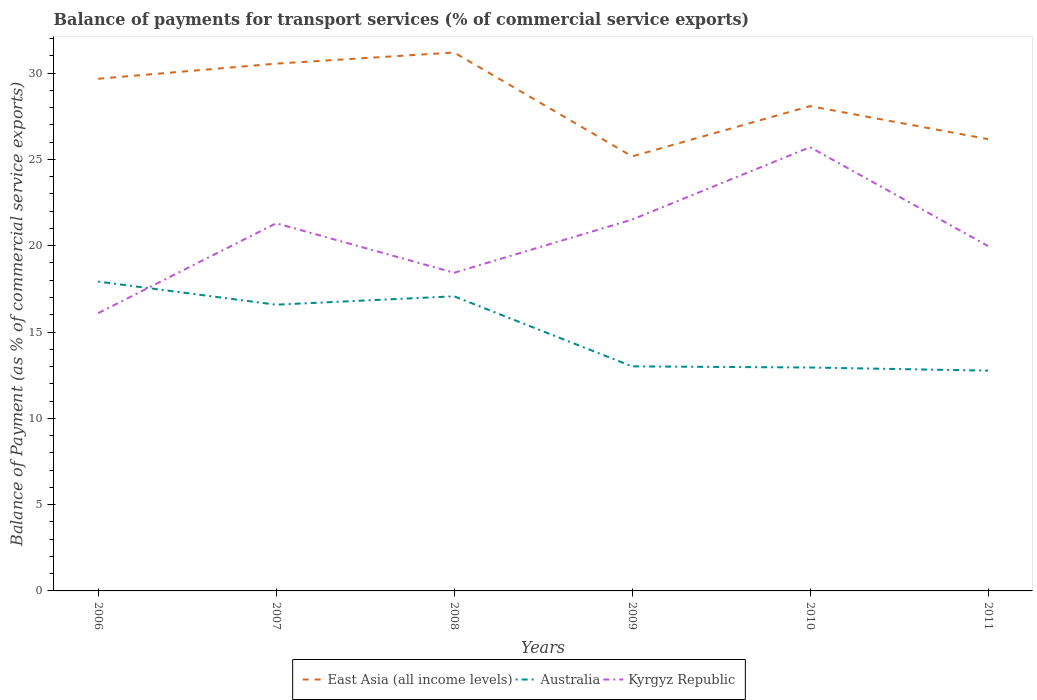How many different coloured lines are there?
Your answer should be very brief. 3. Does the line corresponding to East Asia (all income levels) intersect with the line corresponding to Australia?
Offer a terse response. No. Across all years, what is the maximum balance of payments for transport services in Kyrgyz Republic?
Keep it short and to the point. 16.09. What is the total balance of payments for transport services in East Asia (all income levels) in the graph?
Your answer should be very brief. 5.02. What is the difference between the highest and the second highest balance of payments for transport services in East Asia (all income levels)?
Give a very brief answer. 6.02. Is the balance of payments for transport services in East Asia (all income levels) strictly greater than the balance of payments for transport services in Australia over the years?
Give a very brief answer. No. How many lines are there?
Offer a very short reply. 3. What is the difference between two consecutive major ticks on the Y-axis?
Offer a terse response. 5. Does the graph contain any zero values?
Your response must be concise. No. Where does the legend appear in the graph?
Offer a very short reply. Bottom center. How many legend labels are there?
Provide a succinct answer. 3. What is the title of the graph?
Your answer should be very brief. Balance of payments for transport services (% of commercial service exports). Does "Swaziland" appear as one of the legend labels in the graph?
Ensure brevity in your answer.  No. What is the label or title of the Y-axis?
Your answer should be very brief. Balance of Payment (as % of commercial service exports). What is the Balance of Payment (as % of commercial service exports) of East Asia (all income levels) in 2006?
Offer a very short reply. 29.67. What is the Balance of Payment (as % of commercial service exports) in Australia in 2006?
Give a very brief answer. 17.92. What is the Balance of Payment (as % of commercial service exports) in Kyrgyz Republic in 2006?
Offer a very short reply. 16.09. What is the Balance of Payment (as % of commercial service exports) of East Asia (all income levels) in 2007?
Provide a short and direct response. 30.55. What is the Balance of Payment (as % of commercial service exports) in Australia in 2007?
Keep it short and to the point. 16.58. What is the Balance of Payment (as % of commercial service exports) of Kyrgyz Republic in 2007?
Keep it short and to the point. 21.3. What is the Balance of Payment (as % of commercial service exports) in East Asia (all income levels) in 2008?
Your answer should be very brief. 31.2. What is the Balance of Payment (as % of commercial service exports) in Australia in 2008?
Ensure brevity in your answer.  17.07. What is the Balance of Payment (as % of commercial service exports) of Kyrgyz Republic in 2008?
Give a very brief answer. 18.43. What is the Balance of Payment (as % of commercial service exports) in East Asia (all income levels) in 2009?
Your response must be concise. 25.18. What is the Balance of Payment (as % of commercial service exports) of Australia in 2009?
Your response must be concise. 13.01. What is the Balance of Payment (as % of commercial service exports) of Kyrgyz Republic in 2009?
Ensure brevity in your answer.  21.52. What is the Balance of Payment (as % of commercial service exports) of East Asia (all income levels) in 2010?
Your response must be concise. 28.09. What is the Balance of Payment (as % of commercial service exports) of Australia in 2010?
Offer a terse response. 12.94. What is the Balance of Payment (as % of commercial service exports) of Kyrgyz Republic in 2010?
Keep it short and to the point. 25.71. What is the Balance of Payment (as % of commercial service exports) in East Asia (all income levels) in 2011?
Your answer should be compact. 26.18. What is the Balance of Payment (as % of commercial service exports) in Australia in 2011?
Ensure brevity in your answer.  12.76. What is the Balance of Payment (as % of commercial service exports) in Kyrgyz Republic in 2011?
Offer a very short reply. 19.98. Across all years, what is the maximum Balance of Payment (as % of commercial service exports) in East Asia (all income levels)?
Your answer should be compact. 31.2. Across all years, what is the maximum Balance of Payment (as % of commercial service exports) of Australia?
Offer a terse response. 17.92. Across all years, what is the maximum Balance of Payment (as % of commercial service exports) of Kyrgyz Republic?
Provide a succinct answer. 25.71. Across all years, what is the minimum Balance of Payment (as % of commercial service exports) of East Asia (all income levels)?
Offer a terse response. 25.18. Across all years, what is the minimum Balance of Payment (as % of commercial service exports) of Australia?
Ensure brevity in your answer.  12.76. Across all years, what is the minimum Balance of Payment (as % of commercial service exports) of Kyrgyz Republic?
Provide a short and direct response. 16.09. What is the total Balance of Payment (as % of commercial service exports) of East Asia (all income levels) in the graph?
Give a very brief answer. 170.86. What is the total Balance of Payment (as % of commercial service exports) in Australia in the graph?
Your answer should be compact. 90.29. What is the total Balance of Payment (as % of commercial service exports) in Kyrgyz Republic in the graph?
Provide a short and direct response. 123.04. What is the difference between the Balance of Payment (as % of commercial service exports) of East Asia (all income levels) in 2006 and that in 2007?
Ensure brevity in your answer.  -0.88. What is the difference between the Balance of Payment (as % of commercial service exports) of Australia in 2006 and that in 2007?
Your answer should be very brief. 1.34. What is the difference between the Balance of Payment (as % of commercial service exports) in Kyrgyz Republic in 2006 and that in 2007?
Offer a very short reply. -5.21. What is the difference between the Balance of Payment (as % of commercial service exports) of East Asia (all income levels) in 2006 and that in 2008?
Keep it short and to the point. -1.52. What is the difference between the Balance of Payment (as % of commercial service exports) of Australia in 2006 and that in 2008?
Ensure brevity in your answer.  0.85. What is the difference between the Balance of Payment (as % of commercial service exports) in Kyrgyz Republic in 2006 and that in 2008?
Your response must be concise. -2.34. What is the difference between the Balance of Payment (as % of commercial service exports) in East Asia (all income levels) in 2006 and that in 2009?
Offer a very short reply. 4.5. What is the difference between the Balance of Payment (as % of commercial service exports) in Australia in 2006 and that in 2009?
Give a very brief answer. 4.91. What is the difference between the Balance of Payment (as % of commercial service exports) in Kyrgyz Republic in 2006 and that in 2009?
Provide a short and direct response. -5.42. What is the difference between the Balance of Payment (as % of commercial service exports) in East Asia (all income levels) in 2006 and that in 2010?
Provide a short and direct response. 1.59. What is the difference between the Balance of Payment (as % of commercial service exports) in Australia in 2006 and that in 2010?
Keep it short and to the point. 4.98. What is the difference between the Balance of Payment (as % of commercial service exports) of Kyrgyz Republic in 2006 and that in 2010?
Provide a short and direct response. -9.62. What is the difference between the Balance of Payment (as % of commercial service exports) of East Asia (all income levels) in 2006 and that in 2011?
Offer a very short reply. 3.5. What is the difference between the Balance of Payment (as % of commercial service exports) in Australia in 2006 and that in 2011?
Keep it short and to the point. 5.16. What is the difference between the Balance of Payment (as % of commercial service exports) of Kyrgyz Republic in 2006 and that in 2011?
Give a very brief answer. -3.89. What is the difference between the Balance of Payment (as % of commercial service exports) in East Asia (all income levels) in 2007 and that in 2008?
Your response must be concise. -0.65. What is the difference between the Balance of Payment (as % of commercial service exports) of Australia in 2007 and that in 2008?
Ensure brevity in your answer.  -0.49. What is the difference between the Balance of Payment (as % of commercial service exports) in Kyrgyz Republic in 2007 and that in 2008?
Ensure brevity in your answer.  2.87. What is the difference between the Balance of Payment (as % of commercial service exports) in East Asia (all income levels) in 2007 and that in 2009?
Provide a short and direct response. 5.37. What is the difference between the Balance of Payment (as % of commercial service exports) in Australia in 2007 and that in 2009?
Offer a terse response. 3.57. What is the difference between the Balance of Payment (as % of commercial service exports) of Kyrgyz Republic in 2007 and that in 2009?
Your answer should be very brief. -0.21. What is the difference between the Balance of Payment (as % of commercial service exports) of East Asia (all income levels) in 2007 and that in 2010?
Your answer should be very brief. 2.46. What is the difference between the Balance of Payment (as % of commercial service exports) in Australia in 2007 and that in 2010?
Make the answer very short. 3.64. What is the difference between the Balance of Payment (as % of commercial service exports) of Kyrgyz Republic in 2007 and that in 2010?
Give a very brief answer. -4.41. What is the difference between the Balance of Payment (as % of commercial service exports) in East Asia (all income levels) in 2007 and that in 2011?
Offer a terse response. 4.37. What is the difference between the Balance of Payment (as % of commercial service exports) of Australia in 2007 and that in 2011?
Offer a terse response. 3.82. What is the difference between the Balance of Payment (as % of commercial service exports) in Kyrgyz Republic in 2007 and that in 2011?
Your response must be concise. 1.32. What is the difference between the Balance of Payment (as % of commercial service exports) in East Asia (all income levels) in 2008 and that in 2009?
Keep it short and to the point. 6.02. What is the difference between the Balance of Payment (as % of commercial service exports) in Australia in 2008 and that in 2009?
Keep it short and to the point. 4.06. What is the difference between the Balance of Payment (as % of commercial service exports) of Kyrgyz Republic in 2008 and that in 2009?
Provide a succinct answer. -3.08. What is the difference between the Balance of Payment (as % of commercial service exports) of East Asia (all income levels) in 2008 and that in 2010?
Your answer should be compact. 3.11. What is the difference between the Balance of Payment (as % of commercial service exports) of Australia in 2008 and that in 2010?
Give a very brief answer. 4.12. What is the difference between the Balance of Payment (as % of commercial service exports) of Kyrgyz Republic in 2008 and that in 2010?
Your answer should be very brief. -7.28. What is the difference between the Balance of Payment (as % of commercial service exports) in East Asia (all income levels) in 2008 and that in 2011?
Offer a terse response. 5.02. What is the difference between the Balance of Payment (as % of commercial service exports) in Australia in 2008 and that in 2011?
Offer a terse response. 4.31. What is the difference between the Balance of Payment (as % of commercial service exports) of Kyrgyz Republic in 2008 and that in 2011?
Ensure brevity in your answer.  -1.55. What is the difference between the Balance of Payment (as % of commercial service exports) in East Asia (all income levels) in 2009 and that in 2010?
Keep it short and to the point. -2.91. What is the difference between the Balance of Payment (as % of commercial service exports) in Australia in 2009 and that in 2010?
Provide a short and direct response. 0.06. What is the difference between the Balance of Payment (as % of commercial service exports) in Kyrgyz Republic in 2009 and that in 2010?
Give a very brief answer. -4.19. What is the difference between the Balance of Payment (as % of commercial service exports) of East Asia (all income levels) in 2009 and that in 2011?
Provide a succinct answer. -1. What is the difference between the Balance of Payment (as % of commercial service exports) of Australia in 2009 and that in 2011?
Give a very brief answer. 0.25. What is the difference between the Balance of Payment (as % of commercial service exports) in Kyrgyz Republic in 2009 and that in 2011?
Provide a short and direct response. 1.53. What is the difference between the Balance of Payment (as % of commercial service exports) in East Asia (all income levels) in 2010 and that in 2011?
Offer a very short reply. 1.91. What is the difference between the Balance of Payment (as % of commercial service exports) of Australia in 2010 and that in 2011?
Offer a terse response. 0.18. What is the difference between the Balance of Payment (as % of commercial service exports) of Kyrgyz Republic in 2010 and that in 2011?
Make the answer very short. 5.73. What is the difference between the Balance of Payment (as % of commercial service exports) in East Asia (all income levels) in 2006 and the Balance of Payment (as % of commercial service exports) in Australia in 2007?
Offer a terse response. 13.09. What is the difference between the Balance of Payment (as % of commercial service exports) of East Asia (all income levels) in 2006 and the Balance of Payment (as % of commercial service exports) of Kyrgyz Republic in 2007?
Make the answer very short. 8.37. What is the difference between the Balance of Payment (as % of commercial service exports) of Australia in 2006 and the Balance of Payment (as % of commercial service exports) of Kyrgyz Republic in 2007?
Your answer should be compact. -3.38. What is the difference between the Balance of Payment (as % of commercial service exports) in East Asia (all income levels) in 2006 and the Balance of Payment (as % of commercial service exports) in Australia in 2008?
Keep it short and to the point. 12.6. What is the difference between the Balance of Payment (as % of commercial service exports) of East Asia (all income levels) in 2006 and the Balance of Payment (as % of commercial service exports) of Kyrgyz Republic in 2008?
Your answer should be very brief. 11.24. What is the difference between the Balance of Payment (as % of commercial service exports) in Australia in 2006 and the Balance of Payment (as % of commercial service exports) in Kyrgyz Republic in 2008?
Provide a short and direct response. -0.51. What is the difference between the Balance of Payment (as % of commercial service exports) of East Asia (all income levels) in 2006 and the Balance of Payment (as % of commercial service exports) of Australia in 2009?
Provide a succinct answer. 16.66. What is the difference between the Balance of Payment (as % of commercial service exports) of East Asia (all income levels) in 2006 and the Balance of Payment (as % of commercial service exports) of Kyrgyz Republic in 2009?
Ensure brevity in your answer.  8.16. What is the difference between the Balance of Payment (as % of commercial service exports) in Australia in 2006 and the Balance of Payment (as % of commercial service exports) in Kyrgyz Republic in 2009?
Give a very brief answer. -3.59. What is the difference between the Balance of Payment (as % of commercial service exports) in East Asia (all income levels) in 2006 and the Balance of Payment (as % of commercial service exports) in Australia in 2010?
Give a very brief answer. 16.73. What is the difference between the Balance of Payment (as % of commercial service exports) of East Asia (all income levels) in 2006 and the Balance of Payment (as % of commercial service exports) of Kyrgyz Republic in 2010?
Make the answer very short. 3.96. What is the difference between the Balance of Payment (as % of commercial service exports) in Australia in 2006 and the Balance of Payment (as % of commercial service exports) in Kyrgyz Republic in 2010?
Your answer should be very brief. -7.79. What is the difference between the Balance of Payment (as % of commercial service exports) of East Asia (all income levels) in 2006 and the Balance of Payment (as % of commercial service exports) of Australia in 2011?
Ensure brevity in your answer.  16.91. What is the difference between the Balance of Payment (as % of commercial service exports) of East Asia (all income levels) in 2006 and the Balance of Payment (as % of commercial service exports) of Kyrgyz Republic in 2011?
Your answer should be very brief. 9.69. What is the difference between the Balance of Payment (as % of commercial service exports) of Australia in 2006 and the Balance of Payment (as % of commercial service exports) of Kyrgyz Republic in 2011?
Offer a very short reply. -2.06. What is the difference between the Balance of Payment (as % of commercial service exports) of East Asia (all income levels) in 2007 and the Balance of Payment (as % of commercial service exports) of Australia in 2008?
Offer a very short reply. 13.48. What is the difference between the Balance of Payment (as % of commercial service exports) in East Asia (all income levels) in 2007 and the Balance of Payment (as % of commercial service exports) in Kyrgyz Republic in 2008?
Keep it short and to the point. 12.12. What is the difference between the Balance of Payment (as % of commercial service exports) in Australia in 2007 and the Balance of Payment (as % of commercial service exports) in Kyrgyz Republic in 2008?
Keep it short and to the point. -1.85. What is the difference between the Balance of Payment (as % of commercial service exports) of East Asia (all income levels) in 2007 and the Balance of Payment (as % of commercial service exports) of Australia in 2009?
Provide a succinct answer. 17.54. What is the difference between the Balance of Payment (as % of commercial service exports) in East Asia (all income levels) in 2007 and the Balance of Payment (as % of commercial service exports) in Kyrgyz Republic in 2009?
Give a very brief answer. 9.03. What is the difference between the Balance of Payment (as % of commercial service exports) of Australia in 2007 and the Balance of Payment (as % of commercial service exports) of Kyrgyz Republic in 2009?
Give a very brief answer. -4.93. What is the difference between the Balance of Payment (as % of commercial service exports) in East Asia (all income levels) in 2007 and the Balance of Payment (as % of commercial service exports) in Australia in 2010?
Ensure brevity in your answer.  17.6. What is the difference between the Balance of Payment (as % of commercial service exports) in East Asia (all income levels) in 2007 and the Balance of Payment (as % of commercial service exports) in Kyrgyz Republic in 2010?
Provide a succinct answer. 4.84. What is the difference between the Balance of Payment (as % of commercial service exports) in Australia in 2007 and the Balance of Payment (as % of commercial service exports) in Kyrgyz Republic in 2010?
Provide a short and direct response. -9.13. What is the difference between the Balance of Payment (as % of commercial service exports) of East Asia (all income levels) in 2007 and the Balance of Payment (as % of commercial service exports) of Australia in 2011?
Offer a terse response. 17.79. What is the difference between the Balance of Payment (as % of commercial service exports) of East Asia (all income levels) in 2007 and the Balance of Payment (as % of commercial service exports) of Kyrgyz Republic in 2011?
Offer a terse response. 10.57. What is the difference between the Balance of Payment (as % of commercial service exports) of Australia in 2007 and the Balance of Payment (as % of commercial service exports) of Kyrgyz Republic in 2011?
Keep it short and to the point. -3.4. What is the difference between the Balance of Payment (as % of commercial service exports) of East Asia (all income levels) in 2008 and the Balance of Payment (as % of commercial service exports) of Australia in 2009?
Provide a succinct answer. 18.19. What is the difference between the Balance of Payment (as % of commercial service exports) in East Asia (all income levels) in 2008 and the Balance of Payment (as % of commercial service exports) in Kyrgyz Republic in 2009?
Your response must be concise. 9.68. What is the difference between the Balance of Payment (as % of commercial service exports) of Australia in 2008 and the Balance of Payment (as % of commercial service exports) of Kyrgyz Republic in 2009?
Offer a very short reply. -4.45. What is the difference between the Balance of Payment (as % of commercial service exports) of East Asia (all income levels) in 2008 and the Balance of Payment (as % of commercial service exports) of Australia in 2010?
Provide a short and direct response. 18.25. What is the difference between the Balance of Payment (as % of commercial service exports) of East Asia (all income levels) in 2008 and the Balance of Payment (as % of commercial service exports) of Kyrgyz Republic in 2010?
Offer a terse response. 5.49. What is the difference between the Balance of Payment (as % of commercial service exports) of Australia in 2008 and the Balance of Payment (as % of commercial service exports) of Kyrgyz Republic in 2010?
Provide a short and direct response. -8.64. What is the difference between the Balance of Payment (as % of commercial service exports) in East Asia (all income levels) in 2008 and the Balance of Payment (as % of commercial service exports) in Australia in 2011?
Give a very brief answer. 18.43. What is the difference between the Balance of Payment (as % of commercial service exports) of East Asia (all income levels) in 2008 and the Balance of Payment (as % of commercial service exports) of Kyrgyz Republic in 2011?
Your answer should be compact. 11.21. What is the difference between the Balance of Payment (as % of commercial service exports) in Australia in 2008 and the Balance of Payment (as % of commercial service exports) in Kyrgyz Republic in 2011?
Offer a terse response. -2.91. What is the difference between the Balance of Payment (as % of commercial service exports) in East Asia (all income levels) in 2009 and the Balance of Payment (as % of commercial service exports) in Australia in 2010?
Your answer should be very brief. 12.23. What is the difference between the Balance of Payment (as % of commercial service exports) in East Asia (all income levels) in 2009 and the Balance of Payment (as % of commercial service exports) in Kyrgyz Republic in 2010?
Provide a short and direct response. -0.53. What is the difference between the Balance of Payment (as % of commercial service exports) in Australia in 2009 and the Balance of Payment (as % of commercial service exports) in Kyrgyz Republic in 2010?
Ensure brevity in your answer.  -12.7. What is the difference between the Balance of Payment (as % of commercial service exports) of East Asia (all income levels) in 2009 and the Balance of Payment (as % of commercial service exports) of Australia in 2011?
Your answer should be compact. 12.41. What is the difference between the Balance of Payment (as % of commercial service exports) of East Asia (all income levels) in 2009 and the Balance of Payment (as % of commercial service exports) of Kyrgyz Republic in 2011?
Your response must be concise. 5.19. What is the difference between the Balance of Payment (as % of commercial service exports) in Australia in 2009 and the Balance of Payment (as % of commercial service exports) in Kyrgyz Republic in 2011?
Your answer should be very brief. -6.97. What is the difference between the Balance of Payment (as % of commercial service exports) in East Asia (all income levels) in 2010 and the Balance of Payment (as % of commercial service exports) in Australia in 2011?
Provide a short and direct response. 15.32. What is the difference between the Balance of Payment (as % of commercial service exports) in East Asia (all income levels) in 2010 and the Balance of Payment (as % of commercial service exports) in Kyrgyz Republic in 2011?
Provide a short and direct response. 8.1. What is the difference between the Balance of Payment (as % of commercial service exports) of Australia in 2010 and the Balance of Payment (as % of commercial service exports) of Kyrgyz Republic in 2011?
Your answer should be very brief. -7.04. What is the average Balance of Payment (as % of commercial service exports) in East Asia (all income levels) per year?
Your answer should be compact. 28.48. What is the average Balance of Payment (as % of commercial service exports) in Australia per year?
Offer a very short reply. 15.05. What is the average Balance of Payment (as % of commercial service exports) in Kyrgyz Republic per year?
Keep it short and to the point. 20.51. In the year 2006, what is the difference between the Balance of Payment (as % of commercial service exports) in East Asia (all income levels) and Balance of Payment (as % of commercial service exports) in Australia?
Provide a succinct answer. 11.75. In the year 2006, what is the difference between the Balance of Payment (as % of commercial service exports) in East Asia (all income levels) and Balance of Payment (as % of commercial service exports) in Kyrgyz Republic?
Offer a terse response. 13.58. In the year 2006, what is the difference between the Balance of Payment (as % of commercial service exports) in Australia and Balance of Payment (as % of commercial service exports) in Kyrgyz Republic?
Your answer should be compact. 1.83. In the year 2007, what is the difference between the Balance of Payment (as % of commercial service exports) of East Asia (all income levels) and Balance of Payment (as % of commercial service exports) of Australia?
Provide a short and direct response. 13.97. In the year 2007, what is the difference between the Balance of Payment (as % of commercial service exports) of East Asia (all income levels) and Balance of Payment (as % of commercial service exports) of Kyrgyz Republic?
Offer a terse response. 9.25. In the year 2007, what is the difference between the Balance of Payment (as % of commercial service exports) of Australia and Balance of Payment (as % of commercial service exports) of Kyrgyz Republic?
Provide a short and direct response. -4.72. In the year 2008, what is the difference between the Balance of Payment (as % of commercial service exports) of East Asia (all income levels) and Balance of Payment (as % of commercial service exports) of Australia?
Offer a terse response. 14.13. In the year 2008, what is the difference between the Balance of Payment (as % of commercial service exports) in East Asia (all income levels) and Balance of Payment (as % of commercial service exports) in Kyrgyz Republic?
Your response must be concise. 12.76. In the year 2008, what is the difference between the Balance of Payment (as % of commercial service exports) in Australia and Balance of Payment (as % of commercial service exports) in Kyrgyz Republic?
Your answer should be compact. -1.36. In the year 2009, what is the difference between the Balance of Payment (as % of commercial service exports) of East Asia (all income levels) and Balance of Payment (as % of commercial service exports) of Australia?
Ensure brevity in your answer.  12.17. In the year 2009, what is the difference between the Balance of Payment (as % of commercial service exports) in East Asia (all income levels) and Balance of Payment (as % of commercial service exports) in Kyrgyz Republic?
Offer a terse response. 3.66. In the year 2009, what is the difference between the Balance of Payment (as % of commercial service exports) of Australia and Balance of Payment (as % of commercial service exports) of Kyrgyz Republic?
Make the answer very short. -8.51. In the year 2010, what is the difference between the Balance of Payment (as % of commercial service exports) in East Asia (all income levels) and Balance of Payment (as % of commercial service exports) in Australia?
Offer a terse response. 15.14. In the year 2010, what is the difference between the Balance of Payment (as % of commercial service exports) of East Asia (all income levels) and Balance of Payment (as % of commercial service exports) of Kyrgyz Republic?
Give a very brief answer. 2.38. In the year 2010, what is the difference between the Balance of Payment (as % of commercial service exports) in Australia and Balance of Payment (as % of commercial service exports) in Kyrgyz Republic?
Your answer should be very brief. -12.76. In the year 2011, what is the difference between the Balance of Payment (as % of commercial service exports) in East Asia (all income levels) and Balance of Payment (as % of commercial service exports) in Australia?
Provide a succinct answer. 13.41. In the year 2011, what is the difference between the Balance of Payment (as % of commercial service exports) of East Asia (all income levels) and Balance of Payment (as % of commercial service exports) of Kyrgyz Republic?
Provide a succinct answer. 6.19. In the year 2011, what is the difference between the Balance of Payment (as % of commercial service exports) in Australia and Balance of Payment (as % of commercial service exports) in Kyrgyz Republic?
Offer a very short reply. -7.22. What is the ratio of the Balance of Payment (as % of commercial service exports) in East Asia (all income levels) in 2006 to that in 2007?
Offer a terse response. 0.97. What is the ratio of the Balance of Payment (as % of commercial service exports) of Australia in 2006 to that in 2007?
Your answer should be compact. 1.08. What is the ratio of the Balance of Payment (as % of commercial service exports) in Kyrgyz Republic in 2006 to that in 2007?
Offer a very short reply. 0.76. What is the ratio of the Balance of Payment (as % of commercial service exports) of East Asia (all income levels) in 2006 to that in 2008?
Provide a short and direct response. 0.95. What is the ratio of the Balance of Payment (as % of commercial service exports) in Australia in 2006 to that in 2008?
Keep it short and to the point. 1.05. What is the ratio of the Balance of Payment (as % of commercial service exports) of Kyrgyz Republic in 2006 to that in 2008?
Keep it short and to the point. 0.87. What is the ratio of the Balance of Payment (as % of commercial service exports) of East Asia (all income levels) in 2006 to that in 2009?
Make the answer very short. 1.18. What is the ratio of the Balance of Payment (as % of commercial service exports) of Australia in 2006 to that in 2009?
Provide a succinct answer. 1.38. What is the ratio of the Balance of Payment (as % of commercial service exports) in Kyrgyz Republic in 2006 to that in 2009?
Make the answer very short. 0.75. What is the ratio of the Balance of Payment (as % of commercial service exports) in East Asia (all income levels) in 2006 to that in 2010?
Offer a very short reply. 1.06. What is the ratio of the Balance of Payment (as % of commercial service exports) in Australia in 2006 to that in 2010?
Provide a succinct answer. 1.38. What is the ratio of the Balance of Payment (as % of commercial service exports) in Kyrgyz Republic in 2006 to that in 2010?
Make the answer very short. 0.63. What is the ratio of the Balance of Payment (as % of commercial service exports) of East Asia (all income levels) in 2006 to that in 2011?
Keep it short and to the point. 1.13. What is the ratio of the Balance of Payment (as % of commercial service exports) of Australia in 2006 to that in 2011?
Offer a terse response. 1.4. What is the ratio of the Balance of Payment (as % of commercial service exports) in Kyrgyz Republic in 2006 to that in 2011?
Ensure brevity in your answer.  0.81. What is the ratio of the Balance of Payment (as % of commercial service exports) in East Asia (all income levels) in 2007 to that in 2008?
Offer a terse response. 0.98. What is the ratio of the Balance of Payment (as % of commercial service exports) in Australia in 2007 to that in 2008?
Ensure brevity in your answer.  0.97. What is the ratio of the Balance of Payment (as % of commercial service exports) of Kyrgyz Republic in 2007 to that in 2008?
Keep it short and to the point. 1.16. What is the ratio of the Balance of Payment (as % of commercial service exports) in East Asia (all income levels) in 2007 to that in 2009?
Ensure brevity in your answer.  1.21. What is the ratio of the Balance of Payment (as % of commercial service exports) in Australia in 2007 to that in 2009?
Provide a short and direct response. 1.27. What is the ratio of the Balance of Payment (as % of commercial service exports) in East Asia (all income levels) in 2007 to that in 2010?
Provide a short and direct response. 1.09. What is the ratio of the Balance of Payment (as % of commercial service exports) in Australia in 2007 to that in 2010?
Ensure brevity in your answer.  1.28. What is the ratio of the Balance of Payment (as % of commercial service exports) of Kyrgyz Republic in 2007 to that in 2010?
Keep it short and to the point. 0.83. What is the ratio of the Balance of Payment (as % of commercial service exports) in East Asia (all income levels) in 2007 to that in 2011?
Offer a terse response. 1.17. What is the ratio of the Balance of Payment (as % of commercial service exports) in Australia in 2007 to that in 2011?
Offer a terse response. 1.3. What is the ratio of the Balance of Payment (as % of commercial service exports) of Kyrgyz Republic in 2007 to that in 2011?
Provide a short and direct response. 1.07. What is the ratio of the Balance of Payment (as % of commercial service exports) in East Asia (all income levels) in 2008 to that in 2009?
Give a very brief answer. 1.24. What is the ratio of the Balance of Payment (as % of commercial service exports) of Australia in 2008 to that in 2009?
Make the answer very short. 1.31. What is the ratio of the Balance of Payment (as % of commercial service exports) in Kyrgyz Republic in 2008 to that in 2009?
Ensure brevity in your answer.  0.86. What is the ratio of the Balance of Payment (as % of commercial service exports) of East Asia (all income levels) in 2008 to that in 2010?
Make the answer very short. 1.11. What is the ratio of the Balance of Payment (as % of commercial service exports) in Australia in 2008 to that in 2010?
Offer a terse response. 1.32. What is the ratio of the Balance of Payment (as % of commercial service exports) in Kyrgyz Republic in 2008 to that in 2010?
Your answer should be compact. 0.72. What is the ratio of the Balance of Payment (as % of commercial service exports) of East Asia (all income levels) in 2008 to that in 2011?
Ensure brevity in your answer.  1.19. What is the ratio of the Balance of Payment (as % of commercial service exports) of Australia in 2008 to that in 2011?
Ensure brevity in your answer.  1.34. What is the ratio of the Balance of Payment (as % of commercial service exports) in Kyrgyz Republic in 2008 to that in 2011?
Keep it short and to the point. 0.92. What is the ratio of the Balance of Payment (as % of commercial service exports) in East Asia (all income levels) in 2009 to that in 2010?
Ensure brevity in your answer.  0.9. What is the ratio of the Balance of Payment (as % of commercial service exports) in Australia in 2009 to that in 2010?
Offer a terse response. 1. What is the ratio of the Balance of Payment (as % of commercial service exports) of Kyrgyz Republic in 2009 to that in 2010?
Offer a terse response. 0.84. What is the ratio of the Balance of Payment (as % of commercial service exports) in East Asia (all income levels) in 2009 to that in 2011?
Keep it short and to the point. 0.96. What is the ratio of the Balance of Payment (as % of commercial service exports) in Australia in 2009 to that in 2011?
Keep it short and to the point. 1.02. What is the ratio of the Balance of Payment (as % of commercial service exports) of Kyrgyz Republic in 2009 to that in 2011?
Offer a terse response. 1.08. What is the ratio of the Balance of Payment (as % of commercial service exports) in East Asia (all income levels) in 2010 to that in 2011?
Your answer should be compact. 1.07. What is the ratio of the Balance of Payment (as % of commercial service exports) in Australia in 2010 to that in 2011?
Keep it short and to the point. 1.01. What is the ratio of the Balance of Payment (as % of commercial service exports) of Kyrgyz Republic in 2010 to that in 2011?
Your response must be concise. 1.29. What is the difference between the highest and the second highest Balance of Payment (as % of commercial service exports) of East Asia (all income levels)?
Provide a succinct answer. 0.65. What is the difference between the highest and the second highest Balance of Payment (as % of commercial service exports) in Australia?
Make the answer very short. 0.85. What is the difference between the highest and the second highest Balance of Payment (as % of commercial service exports) in Kyrgyz Republic?
Offer a very short reply. 4.19. What is the difference between the highest and the lowest Balance of Payment (as % of commercial service exports) in East Asia (all income levels)?
Your answer should be very brief. 6.02. What is the difference between the highest and the lowest Balance of Payment (as % of commercial service exports) in Australia?
Provide a short and direct response. 5.16. What is the difference between the highest and the lowest Balance of Payment (as % of commercial service exports) in Kyrgyz Republic?
Keep it short and to the point. 9.62. 